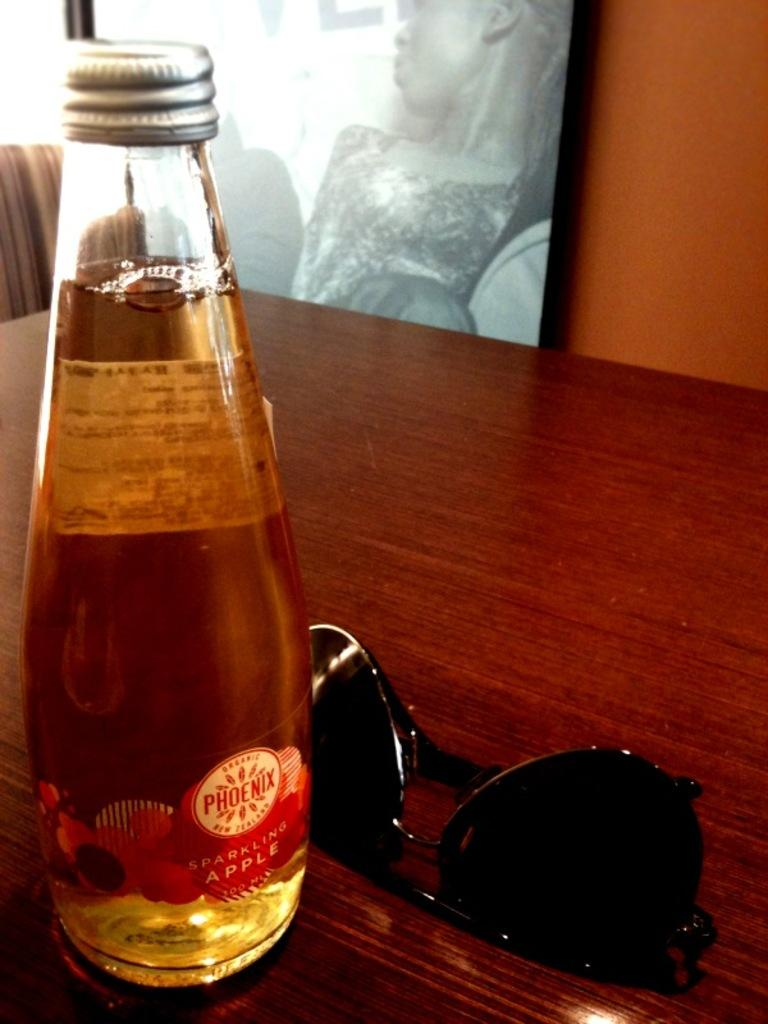Provide a one-sentence caption for the provided image. A bottle of Phoenix sparkling apple is sitting on a table in front of sunglasses. 